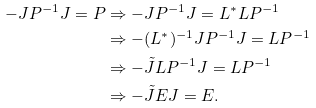<formula> <loc_0><loc_0><loc_500><loc_500>- J P ^ { - 1 } J = P & \Rightarrow - J P ^ { - 1 } J = L ^ { * } L P ^ { - 1 } \\ & \Rightarrow - ( L ^ { * } ) ^ { - 1 } J P ^ { - 1 } J = L P ^ { - 1 } \\ & \Rightarrow - \tilde { J } L P ^ { - 1 } J = L P ^ { - 1 } \\ & \Rightarrow - \tilde { J } E J = E .</formula> 